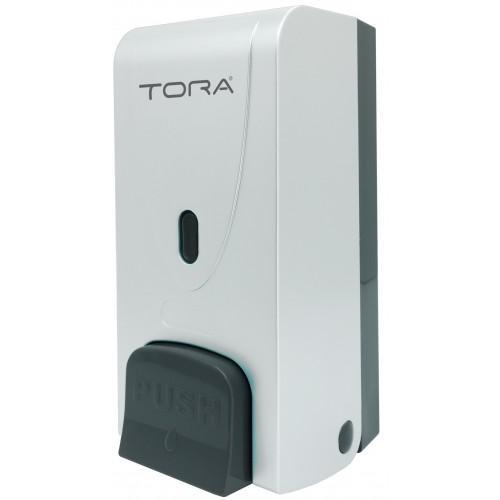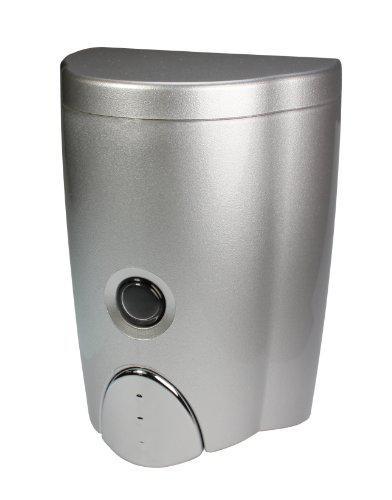The first image is the image on the left, the second image is the image on the right. For the images shown, is this caption "One or more of the dispensers has a chrome finish." true? Answer yes or no. Yes. The first image is the image on the left, the second image is the image on the right. Evaluate the accuracy of this statement regarding the images: "There is a grey button on the machine on the left.". Is it true? Answer yes or no. Yes. 